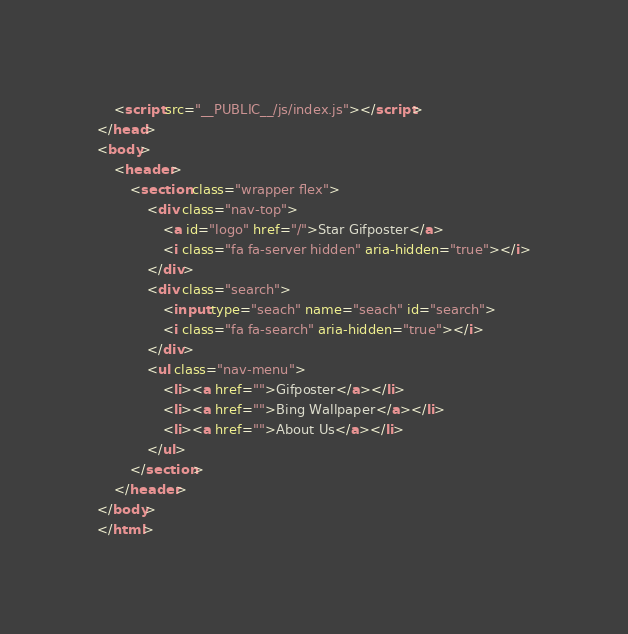Convert code to text. <code><loc_0><loc_0><loc_500><loc_500><_HTML_>	<script src="__PUBLIC__/js/index.js"></script>
</head>
<body>
	<header>
		<section class="wrapper flex">
			<div class="nav-top">
				<a id="logo" href="/">Star Gifposter</a>
				<i class="fa fa-server hidden" aria-hidden="true"></i>
			</div>
			<div class="search">
				<input type="seach" name="seach" id="search">
				<i class="fa fa-search" aria-hidden="true"></i>
			</div>
			<ul class="nav-menu">
				<li><a href="">Gifposter</a></li>
				<li><a href="">Bing Wallpaper</a></li>
				<li><a href="">About Us</a></li>
			</ul>
		</section>
	</header>
</body>
</html></code> 